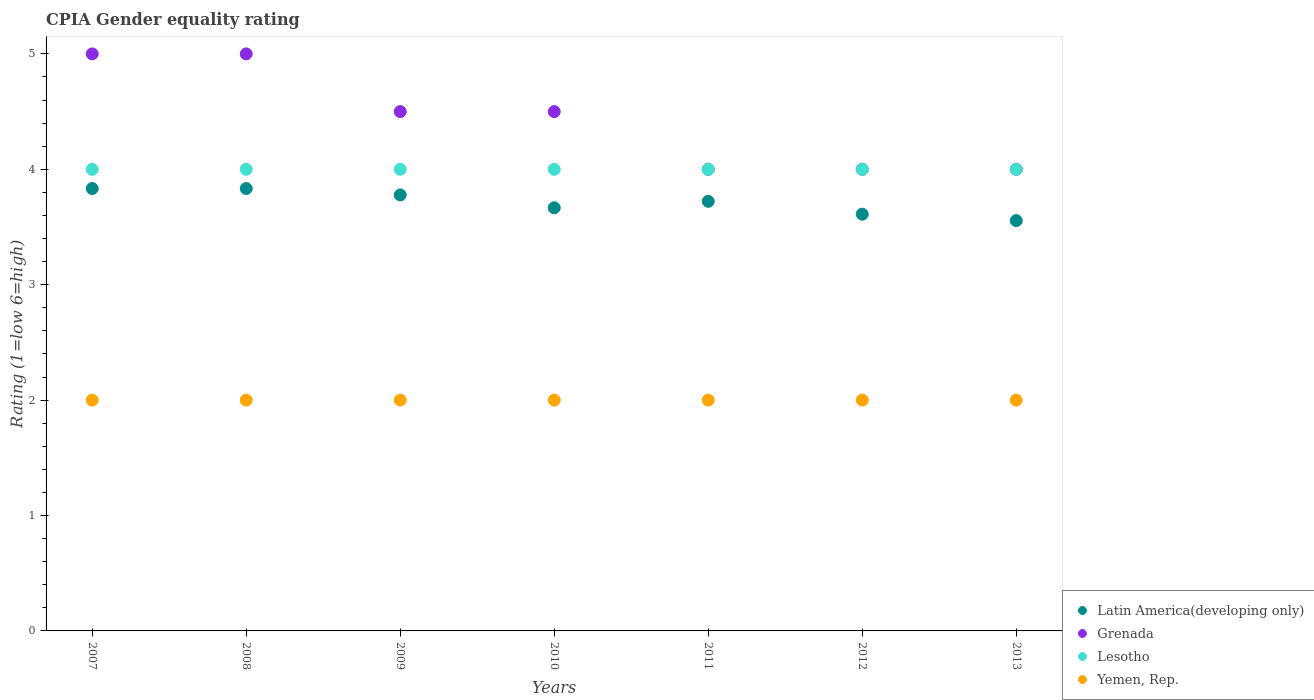Is the number of dotlines equal to the number of legend labels?
Give a very brief answer. Yes. Across all years, what is the maximum CPIA rating in Lesotho?
Make the answer very short. 4. Across all years, what is the minimum CPIA rating in Latin America(developing only)?
Keep it short and to the point. 3.56. What is the total CPIA rating in Lesotho in the graph?
Provide a short and direct response. 28. What is the difference between the CPIA rating in Grenada in 2010 and the CPIA rating in Yemen, Rep. in 2008?
Your answer should be very brief. 2.5. In the year 2012, what is the difference between the CPIA rating in Latin America(developing only) and CPIA rating in Lesotho?
Ensure brevity in your answer.  -0.39. In how many years, is the CPIA rating in Latin America(developing only) greater than 1.4?
Provide a succinct answer. 7. What is the ratio of the CPIA rating in Yemen, Rep. in 2009 to that in 2010?
Keep it short and to the point. 1. What is the difference between the highest and the lowest CPIA rating in Lesotho?
Your answer should be compact. 0. Is it the case that in every year, the sum of the CPIA rating in Latin America(developing only) and CPIA rating in Yemen, Rep.  is greater than the CPIA rating in Grenada?
Your response must be concise. Yes. Does the CPIA rating in Lesotho monotonically increase over the years?
Ensure brevity in your answer.  No. What is the difference between two consecutive major ticks on the Y-axis?
Your response must be concise. 1. Are the values on the major ticks of Y-axis written in scientific E-notation?
Make the answer very short. No. Does the graph contain any zero values?
Your response must be concise. No. Does the graph contain grids?
Provide a succinct answer. No. Where does the legend appear in the graph?
Give a very brief answer. Bottom right. How many legend labels are there?
Your answer should be compact. 4. What is the title of the graph?
Provide a succinct answer. CPIA Gender equality rating. What is the label or title of the X-axis?
Your answer should be compact. Years. What is the Rating (1=low 6=high) in Latin America(developing only) in 2007?
Offer a terse response. 3.83. What is the Rating (1=low 6=high) in Yemen, Rep. in 2007?
Give a very brief answer. 2. What is the Rating (1=low 6=high) in Latin America(developing only) in 2008?
Keep it short and to the point. 3.83. What is the Rating (1=low 6=high) of Latin America(developing only) in 2009?
Ensure brevity in your answer.  3.78. What is the Rating (1=low 6=high) in Grenada in 2009?
Provide a short and direct response. 4.5. What is the Rating (1=low 6=high) of Lesotho in 2009?
Keep it short and to the point. 4. What is the Rating (1=low 6=high) in Yemen, Rep. in 2009?
Your answer should be very brief. 2. What is the Rating (1=low 6=high) in Latin America(developing only) in 2010?
Ensure brevity in your answer.  3.67. What is the Rating (1=low 6=high) in Grenada in 2010?
Offer a very short reply. 4.5. What is the Rating (1=low 6=high) in Yemen, Rep. in 2010?
Make the answer very short. 2. What is the Rating (1=low 6=high) in Latin America(developing only) in 2011?
Ensure brevity in your answer.  3.72. What is the Rating (1=low 6=high) in Lesotho in 2011?
Make the answer very short. 4. What is the Rating (1=low 6=high) of Yemen, Rep. in 2011?
Provide a succinct answer. 2. What is the Rating (1=low 6=high) in Latin America(developing only) in 2012?
Offer a terse response. 3.61. What is the Rating (1=low 6=high) of Grenada in 2012?
Ensure brevity in your answer.  4. What is the Rating (1=low 6=high) in Lesotho in 2012?
Offer a terse response. 4. What is the Rating (1=low 6=high) in Yemen, Rep. in 2012?
Provide a short and direct response. 2. What is the Rating (1=low 6=high) in Latin America(developing only) in 2013?
Provide a short and direct response. 3.56. What is the Rating (1=low 6=high) in Lesotho in 2013?
Provide a succinct answer. 4. What is the Rating (1=low 6=high) of Yemen, Rep. in 2013?
Offer a very short reply. 2. Across all years, what is the maximum Rating (1=low 6=high) in Latin America(developing only)?
Provide a short and direct response. 3.83. Across all years, what is the maximum Rating (1=low 6=high) of Grenada?
Your answer should be very brief. 5. Across all years, what is the maximum Rating (1=low 6=high) in Lesotho?
Your answer should be very brief. 4. Across all years, what is the maximum Rating (1=low 6=high) in Yemen, Rep.?
Provide a short and direct response. 2. Across all years, what is the minimum Rating (1=low 6=high) in Latin America(developing only)?
Make the answer very short. 3.56. What is the total Rating (1=low 6=high) of Grenada in the graph?
Make the answer very short. 31. What is the total Rating (1=low 6=high) in Yemen, Rep. in the graph?
Give a very brief answer. 14. What is the difference between the Rating (1=low 6=high) of Latin America(developing only) in 2007 and that in 2008?
Provide a short and direct response. 0. What is the difference between the Rating (1=low 6=high) of Grenada in 2007 and that in 2008?
Offer a terse response. 0. What is the difference between the Rating (1=low 6=high) in Lesotho in 2007 and that in 2008?
Make the answer very short. 0. What is the difference between the Rating (1=low 6=high) in Yemen, Rep. in 2007 and that in 2008?
Your answer should be very brief. 0. What is the difference between the Rating (1=low 6=high) of Latin America(developing only) in 2007 and that in 2009?
Ensure brevity in your answer.  0.06. What is the difference between the Rating (1=low 6=high) of Grenada in 2007 and that in 2009?
Provide a short and direct response. 0.5. What is the difference between the Rating (1=low 6=high) of Yemen, Rep. in 2007 and that in 2009?
Offer a very short reply. 0. What is the difference between the Rating (1=low 6=high) of Lesotho in 2007 and that in 2010?
Your answer should be very brief. 0. What is the difference between the Rating (1=low 6=high) of Yemen, Rep. in 2007 and that in 2010?
Ensure brevity in your answer.  0. What is the difference between the Rating (1=low 6=high) of Latin America(developing only) in 2007 and that in 2011?
Provide a succinct answer. 0.11. What is the difference between the Rating (1=low 6=high) of Grenada in 2007 and that in 2011?
Make the answer very short. 1. What is the difference between the Rating (1=low 6=high) of Yemen, Rep. in 2007 and that in 2011?
Offer a terse response. 0. What is the difference between the Rating (1=low 6=high) of Latin America(developing only) in 2007 and that in 2012?
Ensure brevity in your answer.  0.22. What is the difference between the Rating (1=low 6=high) in Grenada in 2007 and that in 2012?
Offer a very short reply. 1. What is the difference between the Rating (1=low 6=high) of Latin America(developing only) in 2007 and that in 2013?
Your answer should be compact. 0.28. What is the difference between the Rating (1=low 6=high) of Lesotho in 2007 and that in 2013?
Ensure brevity in your answer.  0. What is the difference between the Rating (1=low 6=high) in Latin America(developing only) in 2008 and that in 2009?
Your answer should be very brief. 0.06. What is the difference between the Rating (1=low 6=high) of Grenada in 2008 and that in 2009?
Your answer should be compact. 0.5. What is the difference between the Rating (1=low 6=high) of Yemen, Rep. in 2008 and that in 2009?
Give a very brief answer. 0. What is the difference between the Rating (1=low 6=high) of Yemen, Rep. in 2008 and that in 2011?
Offer a very short reply. 0. What is the difference between the Rating (1=low 6=high) in Latin America(developing only) in 2008 and that in 2012?
Make the answer very short. 0.22. What is the difference between the Rating (1=low 6=high) in Grenada in 2008 and that in 2012?
Your answer should be compact. 1. What is the difference between the Rating (1=low 6=high) in Yemen, Rep. in 2008 and that in 2012?
Offer a terse response. 0. What is the difference between the Rating (1=low 6=high) in Latin America(developing only) in 2008 and that in 2013?
Your response must be concise. 0.28. What is the difference between the Rating (1=low 6=high) of Grenada in 2008 and that in 2013?
Provide a short and direct response. 1. What is the difference between the Rating (1=low 6=high) in Lesotho in 2008 and that in 2013?
Ensure brevity in your answer.  0. What is the difference between the Rating (1=low 6=high) in Yemen, Rep. in 2009 and that in 2010?
Your response must be concise. 0. What is the difference between the Rating (1=low 6=high) of Latin America(developing only) in 2009 and that in 2011?
Your answer should be compact. 0.06. What is the difference between the Rating (1=low 6=high) in Grenada in 2009 and that in 2011?
Provide a short and direct response. 0.5. What is the difference between the Rating (1=low 6=high) in Yemen, Rep. in 2009 and that in 2011?
Your answer should be very brief. 0. What is the difference between the Rating (1=low 6=high) in Latin America(developing only) in 2009 and that in 2012?
Offer a very short reply. 0.17. What is the difference between the Rating (1=low 6=high) in Grenada in 2009 and that in 2012?
Provide a succinct answer. 0.5. What is the difference between the Rating (1=low 6=high) in Lesotho in 2009 and that in 2012?
Provide a short and direct response. 0. What is the difference between the Rating (1=low 6=high) of Latin America(developing only) in 2009 and that in 2013?
Offer a very short reply. 0.22. What is the difference between the Rating (1=low 6=high) of Grenada in 2009 and that in 2013?
Your answer should be compact. 0.5. What is the difference between the Rating (1=low 6=high) in Latin America(developing only) in 2010 and that in 2011?
Provide a succinct answer. -0.06. What is the difference between the Rating (1=low 6=high) of Yemen, Rep. in 2010 and that in 2011?
Ensure brevity in your answer.  0. What is the difference between the Rating (1=low 6=high) of Latin America(developing only) in 2010 and that in 2012?
Ensure brevity in your answer.  0.06. What is the difference between the Rating (1=low 6=high) of Grenada in 2010 and that in 2012?
Your response must be concise. 0.5. What is the difference between the Rating (1=low 6=high) in Yemen, Rep. in 2010 and that in 2012?
Keep it short and to the point. 0. What is the difference between the Rating (1=low 6=high) in Latin America(developing only) in 2010 and that in 2013?
Your answer should be very brief. 0.11. What is the difference between the Rating (1=low 6=high) of Lesotho in 2010 and that in 2013?
Your answer should be very brief. 0. What is the difference between the Rating (1=low 6=high) of Yemen, Rep. in 2010 and that in 2013?
Provide a short and direct response. 0. What is the difference between the Rating (1=low 6=high) of Grenada in 2011 and that in 2012?
Provide a short and direct response. 0. What is the difference between the Rating (1=low 6=high) of Lesotho in 2011 and that in 2012?
Offer a very short reply. 0. What is the difference between the Rating (1=low 6=high) in Yemen, Rep. in 2011 and that in 2012?
Offer a terse response. 0. What is the difference between the Rating (1=low 6=high) of Latin America(developing only) in 2011 and that in 2013?
Make the answer very short. 0.17. What is the difference between the Rating (1=low 6=high) of Grenada in 2011 and that in 2013?
Your answer should be compact. 0. What is the difference between the Rating (1=low 6=high) of Lesotho in 2011 and that in 2013?
Offer a terse response. 0. What is the difference between the Rating (1=low 6=high) of Latin America(developing only) in 2012 and that in 2013?
Keep it short and to the point. 0.06. What is the difference between the Rating (1=low 6=high) of Latin America(developing only) in 2007 and the Rating (1=low 6=high) of Grenada in 2008?
Give a very brief answer. -1.17. What is the difference between the Rating (1=low 6=high) in Latin America(developing only) in 2007 and the Rating (1=low 6=high) in Yemen, Rep. in 2008?
Offer a very short reply. 1.83. What is the difference between the Rating (1=low 6=high) in Latin America(developing only) in 2007 and the Rating (1=low 6=high) in Grenada in 2009?
Make the answer very short. -0.67. What is the difference between the Rating (1=low 6=high) in Latin America(developing only) in 2007 and the Rating (1=low 6=high) in Lesotho in 2009?
Offer a very short reply. -0.17. What is the difference between the Rating (1=low 6=high) in Latin America(developing only) in 2007 and the Rating (1=low 6=high) in Yemen, Rep. in 2009?
Your answer should be compact. 1.83. What is the difference between the Rating (1=low 6=high) of Grenada in 2007 and the Rating (1=low 6=high) of Yemen, Rep. in 2009?
Provide a succinct answer. 3. What is the difference between the Rating (1=low 6=high) of Lesotho in 2007 and the Rating (1=low 6=high) of Yemen, Rep. in 2009?
Your response must be concise. 2. What is the difference between the Rating (1=low 6=high) of Latin America(developing only) in 2007 and the Rating (1=low 6=high) of Grenada in 2010?
Provide a succinct answer. -0.67. What is the difference between the Rating (1=low 6=high) of Latin America(developing only) in 2007 and the Rating (1=low 6=high) of Lesotho in 2010?
Ensure brevity in your answer.  -0.17. What is the difference between the Rating (1=low 6=high) in Latin America(developing only) in 2007 and the Rating (1=low 6=high) in Yemen, Rep. in 2010?
Offer a terse response. 1.83. What is the difference between the Rating (1=low 6=high) of Grenada in 2007 and the Rating (1=low 6=high) of Lesotho in 2010?
Ensure brevity in your answer.  1. What is the difference between the Rating (1=low 6=high) of Latin America(developing only) in 2007 and the Rating (1=low 6=high) of Grenada in 2011?
Your answer should be compact. -0.17. What is the difference between the Rating (1=low 6=high) of Latin America(developing only) in 2007 and the Rating (1=low 6=high) of Lesotho in 2011?
Make the answer very short. -0.17. What is the difference between the Rating (1=low 6=high) of Latin America(developing only) in 2007 and the Rating (1=low 6=high) of Yemen, Rep. in 2011?
Ensure brevity in your answer.  1.83. What is the difference between the Rating (1=low 6=high) of Grenada in 2007 and the Rating (1=low 6=high) of Lesotho in 2011?
Make the answer very short. 1. What is the difference between the Rating (1=low 6=high) in Latin America(developing only) in 2007 and the Rating (1=low 6=high) in Grenada in 2012?
Give a very brief answer. -0.17. What is the difference between the Rating (1=low 6=high) of Latin America(developing only) in 2007 and the Rating (1=low 6=high) of Lesotho in 2012?
Provide a succinct answer. -0.17. What is the difference between the Rating (1=low 6=high) in Latin America(developing only) in 2007 and the Rating (1=low 6=high) in Yemen, Rep. in 2012?
Ensure brevity in your answer.  1.83. What is the difference between the Rating (1=low 6=high) of Latin America(developing only) in 2007 and the Rating (1=low 6=high) of Grenada in 2013?
Your answer should be very brief. -0.17. What is the difference between the Rating (1=low 6=high) of Latin America(developing only) in 2007 and the Rating (1=low 6=high) of Yemen, Rep. in 2013?
Offer a very short reply. 1.83. What is the difference between the Rating (1=low 6=high) in Lesotho in 2007 and the Rating (1=low 6=high) in Yemen, Rep. in 2013?
Provide a short and direct response. 2. What is the difference between the Rating (1=low 6=high) in Latin America(developing only) in 2008 and the Rating (1=low 6=high) in Grenada in 2009?
Make the answer very short. -0.67. What is the difference between the Rating (1=low 6=high) in Latin America(developing only) in 2008 and the Rating (1=low 6=high) in Lesotho in 2009?
Offer a very short reply. -0.17. What is the difference between the Rating (1=low 6=high) of Latin America(developing only) in 2008 and the Rating (1=low 6=high) of Yemen, Rep. in 2009?
Provide a succinct answer. 1.83. What is the difference between the Rating (1=low 6=high) of Grenada in 2008 and the Rating (1=low 6=high) of Lesotho in 2009?
Your answer should be very brief. 1. What is the difference between the Rating (1=low 6=high) of Grenada in 2008 and the Rating (1=low 6=high) of Yemen, Rep. in 2009?
Your answer should be compact. 3. What is the difference between the Rating (1=low 6=high) in Latin America(developing only) in 2008 and the Rating (1=low 6=high) in Yemen, Rep. in 2010?
Offer a very short reply. 1.83. What is the difference between the Rating (1=low 6=high) of Lesotho in 2008 and the Rating (1=low 6=high) of Yemen, Rep. in 2010?
Ensure brevity in your answer.  2. What is the difference between the Rating (1=low 6=high) in Latin America(developing only) in 2008 and the Rating (1=low 6=high) in Yemen, Rep. in 2011?
Provide a short and direct response. 1.83. What is the difference between the Rating (1=low 6=high) of Lesotho in 2008 and the Rating (1=low 6=high) of Yemen, Rep. in 2011?
Ensure brevity in your answer.  2. What is the difference between the Rating (1=low 6=high) of Latin America(developing only) in 2008 and the Rating (1=low 6=high) of Yemen, Rep. in 2012?
Keep it short and to the point. 1.83. What is the difference between the Rating (1=low 6=high) of Latin America(developing only) in 2008 and the Rating (1=low 6=high) of Grenada in 2013?
Keep it short and to the point. -0.17. What is the difference between the Rating (1=low 6=high) of Latin America(developing only) in 2008 and the Rating (1=low 6=high) of Lesotho in 2013?
Give a very brief answer. -0.17. What is the difference between the Rating (1=low 6=high) of Latin America(developing only) in 2008 and the Rating (1=low 6=high) of Yemen, Rep. in 2013?
Give a very brief answer. 1.83. What is the difference between the Rating (1=low 6=high) in Grenada in 2008 and the Rating (1=low 6=high) in Lesotho in 2013?
Provide a succinct answer. 1. What is the difference between the Rating (1=low 6=high) in Grenada in 2008 and the Rating (1=low 6=high) in Yemen, Rep. in 2013?
Provide a short and direct response. 3. What is the difference between the Rating (1=low 6=high) of Latin America(developing only) in 2009 and the Rating (1=low 6=high) of Grenada in 2010?
Make the answer very short. -0.72. What is the difference between the Rating (1=low 6=high) in Latin America(developing only) in 2009 and the Rating (1=low 6=high) in Lesotho in 2010?
Ensure brevity in your answer.  -0.22. What is the difference between the Rating (1=low 6=high) in Latin America(developing only) in 2009 and the Rating (1=low 6=high) in Yemen, Rep. in 2010?
Offer a terse response. 1.78. What is the difference between the Rating (1=low 6=high) of Grenada in 2009 and the Rating (1=low 6=high) of Lesotho in 2010?
Your answer should be compact. 0.5. What is the difference between the Rating (1=low 6=high) in Lesotho in 2009 and the Rating (1=low 6=high) in Yemen, Rep. in 2010?
Ensure brevity in your answer.  2. What is the difference between the Rating (1=low 6=high) in Latin America(developing only) in 2009 and the Rating (1=low 6=high) in Grenada in 2011?
Your answer should be compact. -0.22. What is the difference between the Rating (1=low 6=high) in Latin America(developing only) in 2009 and the Rating (1=low 6=high) in Lesotho in 2011?
Ensure brevity in your answer.  -0.22. What is the difference between the Rating (1=low 6=high) in Latin America(developing only) in 2009 and the Rating (1=low 6=high) in Yemen, Rep. in 2011?
Keep it short and to the point. 1.78. What is the difference between the Rating (1=low 6=high) of Grenada in 2009 and the Rating (1=low 6=high) of Lesotho in 2011?
Your answer should be very brief. 0.5. What is the difference between the Rating (1=low 6=high) in Latin America(developing only) in 2009 and the Rating (1=low 6=high) in Grenada in 2012?
Offer a terse response. -0.22. What is the difference between the Rating (1=low 6=high) in Latin America(developing only) in 2009 and the Rating (1=low 6=high) in Lesotho in 2012?
Provide a short and direct response. -0.22. What is the difference between the Rating (1=low 6=high) in Latin America(developing only) in 2009 and the Rating (1=low 6=high) in Yemen, Rep. in 2012?
Offer a terse response. 1.78. What is the difference between the Rating (1=low 6=high) of Grenada in 2009 and the Rating (1=low 6=high) of Lesotho in 2012?
Give a very brief answer. 0.5. What is the difference between the Rating (1=low 6=high) in Lesotho in 2009 and the Rating (1=low 6=high) in Yemen, Rep. in 2012?
Offer a terse response. 2. What is the difference between the Rating (1=low 6=high) of Latin America(developing only) in 2009 and the Rating (1=low 6=high) of Grenada in 2013?
Make the answer very short. -0.22. What is the difference between the Rating (1=low 6=high) of Latin America(developing only) in 2009 and the Rating (1=low 6=high) of Lesotho in 2013?
Keep it short and to the point. -0.22. What is the difference between the Rating (1=low 6=high) of Latin America(developing only) in 2009 and the Rating (1=low 6=high) of Yemen, Rep. in 2013?
Keep it short and to the point. 1.78. What is the difference between the Rating (1=low 6=high) of Grenada in 2009 and the Rating (1=low 6=high) of Lesotho in 2013?
Give a very brief answer. 0.5. What is the difference between the Rating (1=low 6=high) in Grenada in 2009 and the Rating (1=low 6=high) in Yemen, Rep. in 2013?
Offer a very short reply. 2.5. What is the difference between the Rating (1=low 6=high) in Lesotho in 2009 and the Rating (1=low 6=high) in Yemen, Rep. in 2013?
Ensure brevity in your answer.  2. What is the difference between the Rating (1=low 6=high) of Latin America(developing only) in 2010 and the Rating (1=low 6=high) of Lesotho in 2011?
Provide a succinct answer. -0.33. What is the difference between the Rating (1=low 6=high) of Latin America(developing only) in 2010 and the Rating (1=low 6=high) of Yemen, Rep. in 2011?
Your response must be concise. 1.67. What is the difference between the Rating (1=low 6=high) in Grenada in 2010 and the Rating (1=low 6=high) in Lesotho in 2011?
Make the answer very short. 0.5. What is the difference between the Rating (1=low 6=high) of Grenada in 2010 and the Rating (1=low 6=high) of Yemen, Rep. in 2011?
Keep it short and to the point. 2.5. What is the difference between the Rating (1=low 6=high) of Latin America(developing only) in 2010 and the Rating (1=low 6=high) of Grenada in 2012?
Offer a terse response. -0.33. What is the difference between the Rating (1=low 6=high) in Latin America(developing only) in 2010 and the Rating (1=low 6=high) in Lesotho in 2012?
Your response must be concise. -0.33. What is the difference between the Rating (1=low 6=high) in Lesotho in 2010 and the Rating (1=low 6=high) in Yemen, Rep. in 2012?
Ensure brevity in your answer.  2. What is the difference between the Rating (1=low 6=high) in Latin America(developing only) in 2010 and the Rating (1=low 6=high) in Grenada in 2013?
Offer a terse response. -0.33. What is the difference between the Rating (1=low 6=high) of Latin America(developing only) in 2010 and the Rating (1=low 6=high) of Yemen, Rep. in 2013?
Provide a succinct answer. 1.67. What is the difference between the Rating (1=low 6=high) of Grenada in 2010 and the Rating (1=low 6=high) of Lesotho in 2013?
Offer a terse response. 0.5. What is the difference between the Rating (1=low 6=high) of Lesotho in 2010 and the Rating (1=low 6=high) of Yemen, Rep. in 2013?
Make the answer very short. 2. What is the difference between the Rating (1=low 6=high) of Latin America(developing only) in 2011 and the Rating (1=low 6=high) of Grenada in 2012?
Offer a terse response. -0.28. What is the difference between the Rating (1=low 6=high) in Latin America(developing only) in 2011 and the Rating (1=low 6=high) in Lesotho in 2012?
Provide a succinct answer. -0.28. What is the difference between the Rating (1=low 6=high) of Latin America(developing only) in 2011 and the Rating (1=low 6=high) of Yemen, Rep. in 2012?
Your response must be concise. 1.72. What is the difference between the Rating (1=low 6=high) of Grenada in 2011 and the Rating (1=low 6=high) of Lesotho in 2012?
Keep it short and to the point. 0. What is the difference between the Rating (1=low 6=high) of Lesotho in 2011 and the Rating (1=low 6=high) of Yemen, Rep. in 2012?
Your response must be concise. 2. What is the difference between the Rating (1=low 6=high) of Latin America(developing only) in 2011 and the Rating (1=low 6=high) of Grenada in 2013?
Offer a terse response. -0.28. What is the difference between the Rating (1=low 6=high) in Latin America(developing only) in 2011 and the Rating (1=low 6=high) in Lesotho in 2013?
Your response must be concise. -0.28. What is the difference between the Rating (1=low 6=high) in Latin America(developing only) in 2011 and the Rating (1=low 6=high) in Yemen, Rep. in 2013?
Keep it short and to the point. 1.72. What is the difference between the Rating (1=low 6=high) of Grenada in 2011 and the Rating (1=low 6=high) of Lesotho in 2013?
Ensure brevity in your answer.  0. What is the difference between the Rating (1=low 6=high) of Lesotho in 2011 and the Rating (1=low 6=high) of Yemen, Rep. in 2013?
Offer a terse response. 2. What is the difference between the Rating (1=low 6=high) in Latin America(developing only) in 2012 and the Rating (1=low 6=high) in Grenada in 2013?
Make the answer very short. -0.39. What is the difference between the Rating (1=low 6=high) of Latin America(developing only) in 2012 and the Rating (1=low 6=high) of Lesotho in 2013?
Provide a succinct answer. -0.39. What is the difference between the Rating (1=low 6=high) in Latin America(developing only) in 2012 and the Rating (1=low 6=high) in Yemen, Rep. in 2013?
Your answer should be compact. 1.61. What is the difference between the Rating (1=low 6=high) of Grenada in 2012 and the Rating (1=low 6=high) of Lesotho in 2013?
Ensure brevity in your answer.  0. What is the difference between the Rating (1=low 6=high) in Grenada in 2012 and the Rating (1=low 6=high) in Yemen, Rep. in 2013?
Ensure brevity in your answer.  2. What is the difference between the Rating (1=low 6=high) in Lesotho in 2012 and the Rating (1=low 6=high) in Yemen, Rep. in 2013?
Provide a succinct answer. 2. What is the average Rating (1=low 6=high) in Latin America(developing only) per year?
Offer a terse response. 3.71. What is the average Rating (1=low 6=high) in Grenada per year?
Provide a succinct answer. 4.43. What is the average Rating (1=low 6=high) of Yemen, Rep. per year?
Your response must be concise. 2. In the year 2007, what is the difference between the Rating (1=low 6=high) of Latin America(developing only) and Rating (1=low 6=high) of Grenada?
Provide a short and direct response. -1.17. In the year 2007, what is the difference between the Rating (1=low 6=high) of Latin America(developing only) and Rating (1=low 6=high) of Lesotho?
Provide a short and direct response. -0.17. In the year 2007, what is the difference between the Rating (1=low 6=high) in Latin America(developing only) and Rating (1=low 6=high) in Yemen, Rep.?
Ensure brevity in your answer.  1.83. In the year 2008, what is the difference between the Rating (1=low 6=high) of Latin America(developing only) and Rating (1=low 6=high) of Grenada?
Your response must be concise. -1.17. In the year 2008, what is the difference between the Rating (1=low 6=high) in Latin America(developing only) and Rating (1=low 6=high) in Lesotho?
Give a very brief answer. -0.17. In the year 2008, what is the difference between the Rating (1=low 6=high) in Latin America(developing only) and Rating (1=low 6=high) in Yemen, Rep.?
Provide a succinct answer. 1.83. In the year 2008, what is the difference between the Rating (1=low 6=high) in Grenada and Rating (1=low 6=high) in Yemen, Rep.?
Your response must be concise. 3. In the year 2008, what is the difference between the Rating (1=low 6=high) of Lesotho and Rating (1=low 6=high) of Yemen, Rep.?
Make the answer very short. 2. In the year 2009, what is the difference between the Rating (1=low 6=high) of Latin America(developing only) and Rating (1=low 6=high) of Grenada?
Your answer should be compact. -0.72. In the year 2009, what is the difference between the Rating (1=low 6=high) in Latin America(developing only) and Rating (1=low 6=high) in Lesotho?
Offer a terse response. -0.22. In the year 2009, what is the difference between the Rating (1=low 6=high) in Latin America(developing only) and Rating (1=low 6=high) in Yemen, Rep.?
Give a very brief answer. 1.78. In the year 2009, what is the difference between the Rating (1=low 6=high) in Lesotho and Rating (1=low 6=high) in Yemen, Rep.?
Your answer should be very brief. 2. In the year 2010, what is the difference between the Rating (1=low 6=high) of Latin America(developing only) and Rating (1=low 6=high) of Yemen, Rep.?
Your response must be concise. 1.67. In the year 2011, what is the difference between the Rating (1=low 6=high) of Latin America(developing only) and Rating (1=low 6=high) of Grenada?
Provide a short and direct response. -0.28. In the year 2011, what is the difference between the Rating (1=low 6=high) in Latin America(developing only) and Rating (1=low 6=high) in Lesotho?
Keep it short and to the point. -0.28. In the year 2011, what is the difference between the Rating (1=low 6=high) in Latin America(developing only) and Rating (1=low 6=high) in Yemen, Rep.?
Give a very brief answer. 1.72. In the year 2011, what is the difference between the Rating (1=low 6=high) of Grenada and Rating (1=low 6=high) of Lesotho?
Your response must be concise. 0. In the year 2011, what is the difference between the Rating (1=low 6=high) of Grenada and Rating (1=low 6=high) of Yemen, Rep.?
Give a very brief answer. 2. In the year 2012, what is the difference between the Rating (1=low 6=high) in Latin America(developing only) and Rating (1=low 6=high) in Grenada?
Give a very brief answer. -0.39. In the year 2012, what is the difference between the Rating (1=low 6=high) in Latin America(developing only) and Rating (1=low 6=high) in Lesotho?
Ensure brevity in your answer.  -0.39. In the year 2012, what is the difference between the Rating (1=low 6=high) in Latin America(developing only) and Rating (1=low 6=high) in Yemen, Rep.?
Offer a terse response. 1.61. In the year 2012, what is the difference between the Rating (1=low 6=high) in Grenada and Rating (1=low 6=high) in Yemen, Rep.?
Give a very brief answer. 2. In the year 2012, what is the difference between the Rating (1=low 6=high) in Lesotho and Rating (1=low 6=high) in Yemen, Rep.?
Give a very brief answer. 2. In the year 2013, what is the difference between the Rating (1=low 6=high) in Latin America(developing only) and Rating (1=low 6=high) in Grenada?
Your response must be concise. -0.44. In the year 2013, what is the difference between the Rating (1=low 6=high) in Latin America(developing only) and Rating (1=low 6=high) in Lesotho?
Offer a terse response. -0.44. In the year 2013, what is the difference between the Rating (1=low 6=high) of Latin America(developing only) and Rating (1=low 6=high) of Yemen, Rep.?
Offer a very short reply. 1.56. In the year 2013, what is the difference between the Rating (1=low 6=high) of Grenada and Rating (1=low 6=high) of Yemen, Rep.?
Make the answer very short. 2. What is the ratio of the Rating (1=low 6=high) of Yemen, Rep. in 2007 to that in 2008?
Offer a terse response. 1. What is the ratio of the Rating (1=low 6=high) in Latin America(developing only) in 2007 to that in 2009?
Provide a succinct answer. 1.01. What is the ratio of the Rating (1=low 6=high) of Grenada in 2007 to that in 2009?
Provide a succinct answer. 1.11. What is the ratio of the Rating (1=low 6=high) of Yemen, Rep. in 2007 to that in 2009?
Your response must be concise. 1. What is the ratio of the Rating (1=low 6=high) in Latin America(developing only) in 2007 to that in 2010?
Give a very brief answer. 1.05. What is the ratio of the Rating (1=low 6=high) of Yemen, Rep. in 2007 to that in 2010?
Give a very brief answer. 1. What is the ratio of the Rating (1=low 6=high) in Latin America(developing only) in 2007 to that in 2011?
Give a very brief answer. 1.03. What is the ratio of the Rating (1=low 6=high) of Grenada in 2007 to that in 2011?
Give a very brief answer. 1.25. What is the ratio of the Rating (1=low 6=high) in Lesotho in 2007 to that in 2011?
Offer a terse response. 1. What is the ratio of the Rating (1=low 6=high) of Latin America(developing only) in 2007 to that in 2012?
Keep it short and to the point. 1.06. What is the ratio of the Rating (1=low 6=high) of Lesotho in 2007 to that in 2012?
Give a very brief answer. 1. What is the ratio of the Rating (1=low 6=high) in Yemen, Rep. in 2007 to that in 2012?
Make the answer very short. 1. What is the ratio of the Rating (1=low 6=high) in Latin America(developing only) in 2007 to that in 2013?
Your answer should be compact. 1.08. What is the ratio of the Rating (1=low 6=high) of Lesotho in 2007 to that in 2013?
Offer a very short reply. 1. What is the ratio of the Rating (1=low 6=high) of Latin America(developing only) in 2008 to that in 2009?
Your response must be concise. 1.01. What is the ratio of the Rating (1=low 6=high) in Lesotho in 2008 to that in 2009?
Offer a terse response. 1. What is the ratio of the Rating (1=low 6=high) of Latin America(developing only) in 2008 to that in 2010?
Give a very brief answer. 1.05. What is the ratio of the Rating (1=low 6=high) of Yemen, Rep. in 2008 to that in 2010?
Provide a short and direct response. 1. What is the ratio of the Rating (1=low 6=high) of Latin America(developing only) in 2008 to that in 2011?
Your response must be concise. 1.03. What is the ratio of the Rating (1=low 6=high) of Grenada in 2008 to that in 2011?
Provide a succinct answer. 1.25. What is the ratio of the Rating (1=low 6=high) of Latin America(developing only) in 2008 to that in 2012?
Offer a terse response. 1.06. What is the ratio of the Rating (1=low 6=high) in Lesotho in 2008 to that in 2012?
Offer a terse response. 1. What is the ratio of the Rating (1=low 6=high) in Yemen, Rep. in 2008 to that in 2012?
Provide a succinct answer. 1. What is the ratio of the Rating (1=low 6=high) of Latin America(developing only) in 2008 to that in 2013?
Your answer should be very brief. 1.08. What is the ratio of the Rating (1=low 6=high) in Grenada in 2008 to that in 2013?
Your answer should be very brief. 1.25. What is the ratio of the Rating (1=low 6=high) in Yemen, Rep. in 2008 to that in 2013?
Ensure brevity in your answer.  1. What is the ratio of the Rating (1=low 6=high) in Latin America(developing only) in 2009 to that in 2010?
Keep it short and to the point. 1.03. What is the ratio of the Rating (1=low 6=high) of Lesotho in 2009 to that in 2010?
Your response must be concise. 1. What is the ratio of the Rating (1=low 6=high) in Yemen, Rep. in 2009 to that in 2010?
Keep it short and to the point. 1. What is the ratio of the Rating (1=low 6=high) of Latin America(developing only) in 2009 to that in 2011?
Your response must be concise. 1.01. What is the ratio of the Rating (1=low 6=high) in Lesotho in 2009 to that in 2011?
Make the answer very short. 1. What is the ratio of the Rating (1=low 6=high) of Latin America(developing only) in 2009 to that in 2012?
Your answer should be compact. 1.05. What is the ratio of the Rating (1=low 6=high) of Yemen, Rep. in 2009 to that in 2012?
Offer a terse response. 1. What is the ratio of the Rating (1=low 6=high) in Latin America(developing only) in 2009 to that in 2013?
Your response must be concise. 1.06. What is the ratio of the Rating (1=low 6=high) of Latin America(developing only) in 2010 to that in 2011?
Keep it short and to the point. 0.99. What is the ratio of the Rating (1=low 6=high) in Latin America(developing only) in 2010 to that in 2012?
Offer a terse response. 1.02. What is the ratio of the Rating (1=low 6=high) in Yemen, Rep. in 2010 to that in 2012?
Make the answer very short. 1. What is the ratio of the Rating (1=low 6=high) in Latin America(developing only) in 2010 to that in 2013?
Your answer should be very brief. 1.03. What is the ratio of the Rating (1=low 6=high) in Grenada in 2010 to that in 2013?
Your response must be concise. 1.12. What is the ratio of the Rating (1=low 6=high) of Latin America(developing only) in 2011 to that in 2012?
Your response must be concise. 1.03. What is the ratio of the Rating (1=low 6=high) of Grenada in 2011 to that in 2012?
Your answer should be compact. 1. What is the ratio of the Rating (1=low 6=high) of Lesotho in 2011 to that in 2012?
Your answer should be very brief. 1. What is the ratio of the Rating (1=low 6=high) of Yemen, Rep. in 2011 to that in 2012?
Make the answer very short. 1. What is the ratio of the Rating (1=low 6=high) of Latin America(developing only) in 2011 to that in 2013?
Give a very brief answer. 1.05. What is the ratio of the Rating (1=low 6=high) of Grenada in 2011 to that in 2013?
Your answer should be very brief. 1. What is the ratio of the Rating (1=low 6=high) in Latin America(developing only) in 2012 to that in 2013?
Offer a very short reply. 1.02. What is the ratio of the Rating (1=low 6=high) in Yemen, Rep. in 2012 to that in 2013?
Your answer should be compact. 1. What is the difference between the highest and the second highest Rating (1=low 6=high) of Lesotho?
Offer a very short reply. 0. What is the difference between the highest and the second highest Rating (1=low 6=high) in Yemen, Rep.?
Your response must be concise. 0. What is the difference between the highest and the lowest Rating (1=low 6=high) of Latin America(developing only)?
Give a very brief answer. 0.28. 